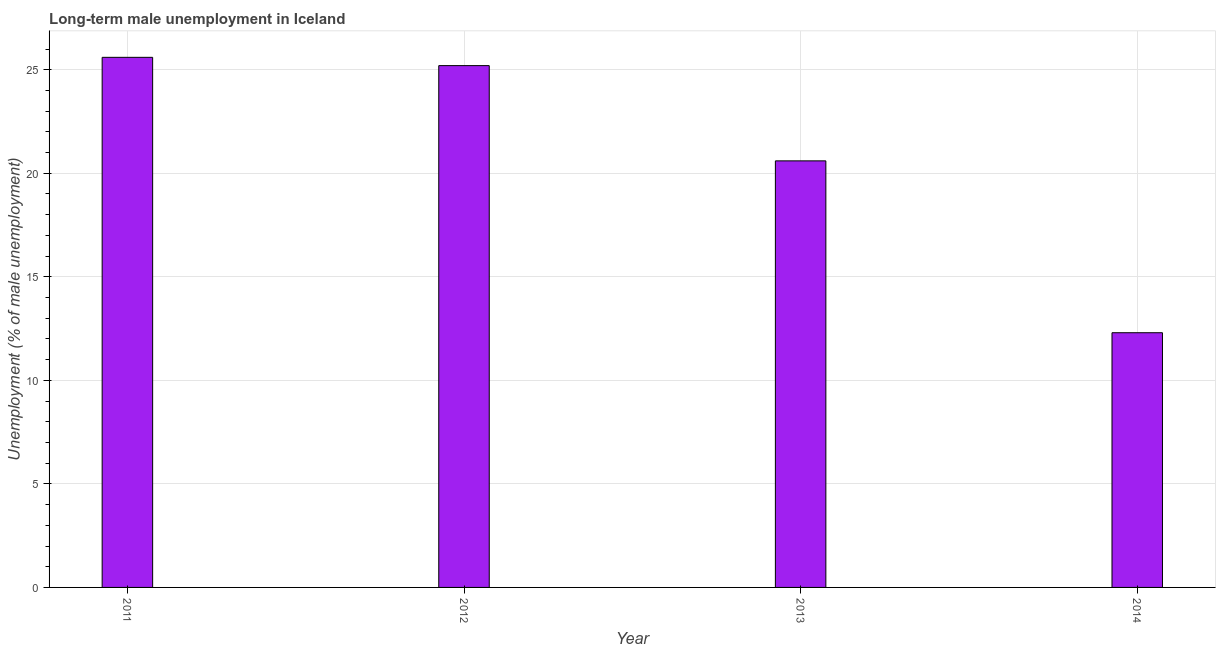Does the graph contain grids?
Make the answer very short. Yes. What is the title of the graph?
Provide a succinct answer. Long-term male unemployment in Iceland. What is the label or title of the Y-axis?
Give a very brief answer. Unemployment (% of male unemployment). What is the long-term male unemployment in 2011?
Give a very brief answer. 25.6. Across all years, what is the maximum long-term male unemployment?
Keep it short and to the point. 25.6. Across all years, what is the minimum long-term male unemployment?
Your answer should be very brief. 12.3. What is the sum of the long-term male unemployment?
Offer a very short reply. 83.7. What is the average long-term male unemployment per year?
Offer a very short reply. 20.93. What is the median long-term male unemployment?
Keep it short and to the point. 22.9. Do a majority of the years between 2014 and 2012 (inclusive) have long-term male unemployment greater than 6 %?
Keep it short and to the point. Yes. What is the ratio of the long-term male unemployment in 2011 to that in 2013?
Give a very brief answer. 1.24. Is the long-term male unemployment in 2013 less than that in 2014?
Provide a succinct answer. No. Are all the bars in the graph horizontal?
Ensure brevity in your answer.  No. What is the difference between two consecutive major ticks on the Y-axis?
Provide a succinct answer. 5. Are the values on the major ticks of Y-axis written in scientific E-notation?
Provide a succinct answer. No. What is the Unemployment (% of male unemployment) in 2011?
Make the answer very short. 25.6. What is the Unemployment (% of male unemployment) in 2012?
Provide a short and direct response. 25.2. What is the Unemployment (% of male unemployment) in 2013?
Provide a short and direct response. 20.6. What is the Unemployment (% of male unemployment) of 2014?
Keep it short and to the point. 12.3. What is the difference between the Unemployment (% of male unemployment) in 2011 and 2014?
Make the answer very short. 13.3. What is the ratio of the Unemployment (% of male unemployment) in 2011 to that in 2013?
Your response must be concise. 1.24. What is the ratio of the Unemployment (% of male unemployment) in 2011 to that in 2014?
Your response must be concise. 2.08. What is the ratio of the Unemployment (% of male unemployment) in 2012 to that in 2013?
Give a very brief answer. 1.22. What is the ratio of the Unemployment (% of male unemployment) in 2012 to that in 2014?
Your response must be concise. 2.05. What is the ratio of the Unemployment (% of male unemployment) in 2013 to that in 2014?
Make the answer very short. 1.68. 